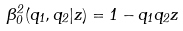<formula> <loc_0><loc_0><loc_500><loc_500>\beta ^ { 2 } _ { 0 } ( q _ { 1 } , q _ { 2 } | z ) = 1 - q _ { 1 } q _ { 2 } z</formula> 